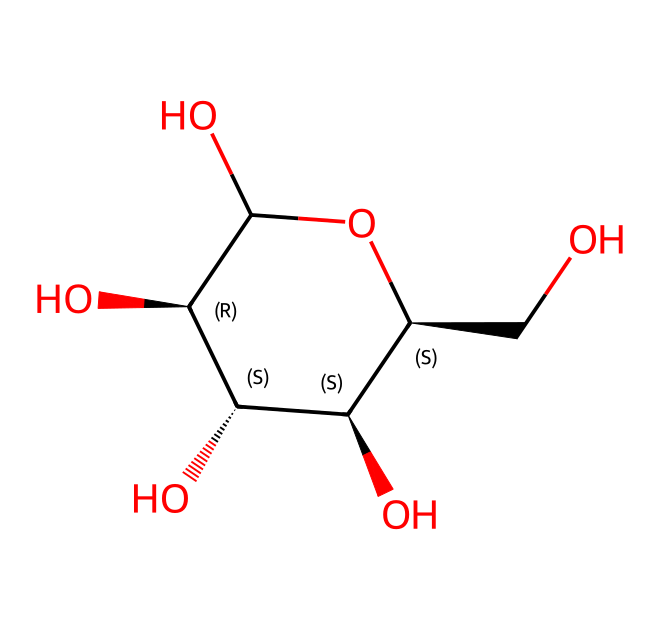What is the molecular formula of glucose? To determine the molecular formula, count the number of carbon (C), hydrogen (H), and oxygen (O) atoms in the structure. The SMILES representation indicates there are 6 carbon atoms, 12 hydrogen atoms, and 6 oxygen atoms. Therefore, the molecular formula is C6H12O6.
Answer: C6H12O6 How many hydroxyl (OH) groups are present in glucose? In the chemical structure, each -OH group is indicated by an oxygen atom bonded to a hydrogen atom. Counting the visible -OH groups in the structure provides a total of 5 hydroxyl groups in glucose.
Answer: 5 What type of molecule is glucose classified as? Glucose is classified as a monosaccharide because it consists of a single sugar molecule. This classification can be determined by identifying that glucose is a simple sugar with a basic structure that cannot be hydrolyzed into simpler sugars.
Answer: monosaccharide How many stereocenters does glucose have? A stereocenter is typically defined as a carbon atom bonded to four different groups. By analyzing the structure, there are 4 carbon atoms in glucose that meet this criterion, making the total number of stereocenters 4.
Answer: 4 What type of carbohydrate does glucose contribute to in larger structures? Glucose serves as a building block for polysaccharides like cellulose and starch, which are made up of long chains of glucose units. This is evident from its structure, which allows it to link together via glycosidic bonds to form more complex carbohydrates.
Answer: polysaccharides Which configuration type does glucose predominantly exhibit? Glucose is predominantly found in the D-configuration, indicated by the arrangement of the hydroxyl group on the highest-numbered chiral carbon (C-5) being on the right in the Fischer projection.
Answer: D-configuration What is the significance of the anomeric carbon in glucose? The anomeric carbon refers to the carbon that becomes a new chiral center upon ring-closure, specifically C-1 in glucose. This carbon's configuration (α or β) determines the properties and reactivity of the sugar, particularly in forming glycosidic bonds in larger carbohydrates.
Answer: C-1 